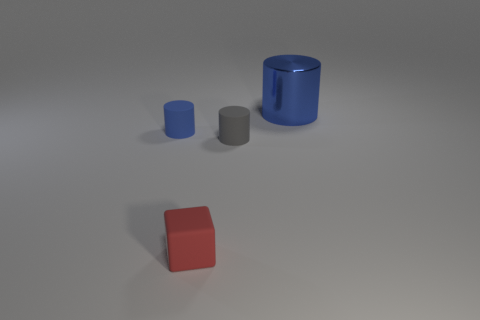Subtract all shiny cylinders. How many cylinders are left? 2 Subtract all blue cubes. How many blue cylinders are left? 2 Subtract all blue cylinders. How many cylinders are left? 1 Add 3 large gray spheres. How many objects exist? 7 Subtract all blocks. How many objects are left? 3 Subtract 1 gray cylinders. How many objects are left? 3 Subtract all green cylinders. Subtract all red spheres. How many cylinders are left? 3 Subtract all big blue shiny blocks. Subtract all blue objects. How many objects are left? 2 Add 2 blue things. How many blue things are left? 4 Add 4 small blue cylinders. How many small blue cylinders exist? 5 